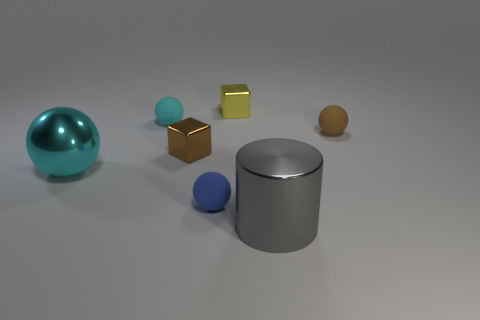Subtract all rubber balls. How many balls are left? 1 Add 1 red shiny cubes. How many objects exist? 8 Subtract 4 balls. How many balls are left? 0 Subtract all yellow cubes. How many cubes are left? 1 Subtract all cylinders. How many objects are left? 6 Subtract 0 purple blocks. How many objects are left? 7 Subtract all cyan cylinders. Subtract all brown cubes. How many cylinders are left? 1 Subtract all gray balls. How many yellow blocks are left? 1 Subtract all brown blocks. Subtract all purple shiny cylinders. How many objects are left? 6 Add 3 big cyan spheres. How many big cyan spheres are left? 4 